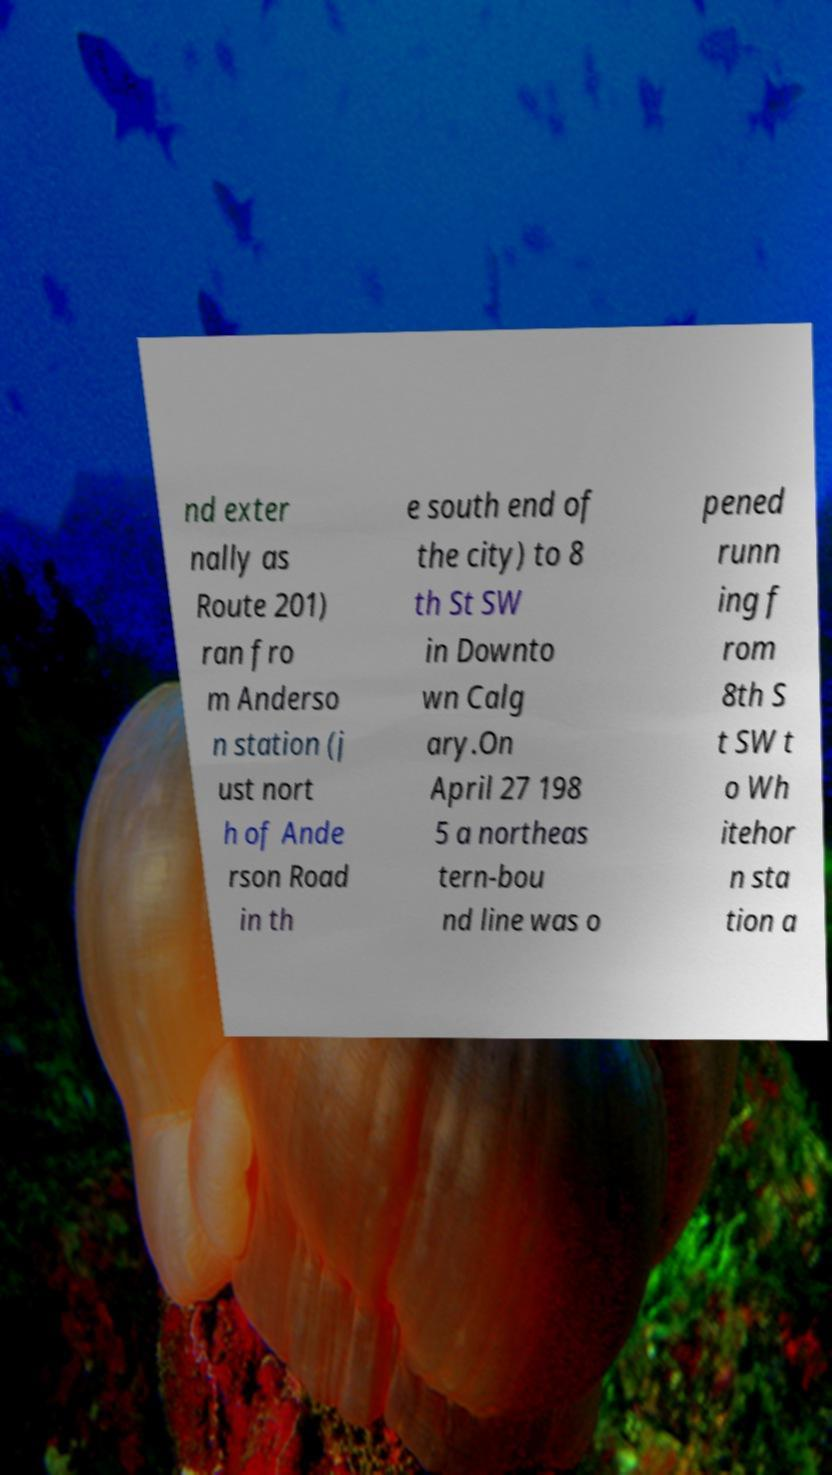What messages or text are displayed in this image? I need them in a readable, typed format. nd exter nally as Route 201) ran fro m Anderso n station (j ust nort h of Ande rson Road in th e south end of the city) to 8 th St SW in Downto wn Calg ary.On April 27 198 5 a northeas tern-bou nd line was o pened runn ing f rom 8th S t SW t o Wh itehor n sta tion a 